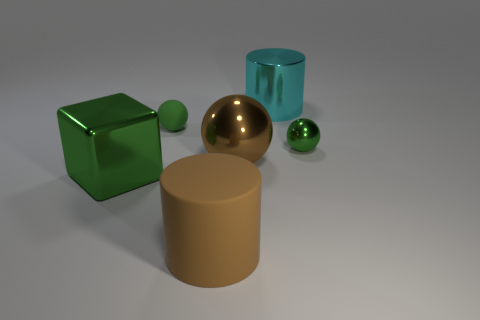What number of objects are small green things or large blue metal cubes?
Offer a terse response. 2. Does the large metal thing on the left side of the matte cylinder have the same shape as the brown thing that is behind the big green metal thing?
Give a very brief answer. No. How many metal things are both in front of the brown ball and behind the green shiny ball?
Offer a very short reply. 0. How many other things are the same size as the green metallic ball?
Ensure brevity in your answer.  1. There is a thing that is both on the left side of the big brown cylinder and in front of the brown metallic object; what is its material?
Provide a succinct answer. Metal. Does the large ball have the same color as the metallic thing that is right of the metallic cylinder?
Provide a succinct answer. No. There is another thing that is the same shape as the cyan thing; what size is it?
Offer a very short reply. Large. There is a object that is behind the big brown matte object and in front of the big ball; what is its shape?
Offer a very short reply. Cube. Does the cyan metal cylinder have the same size as the green object that is to the right of the big brown cylinder?
Your answer should be very brief. No. There is a tiny metal object that is the same shape as the tiny rubber object; what color is it?
Provide a succinct answer. Green. 